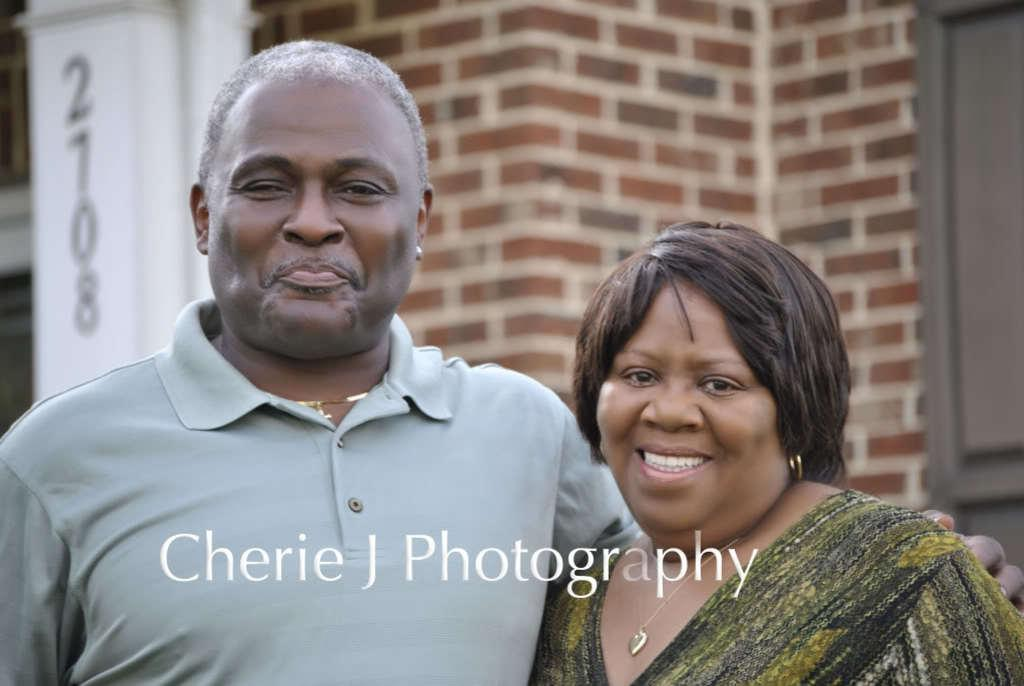How many people are present in the image? There are two people, a man and a woman, present in the image. What expressions do the man and woman have in the image? Both the man and woman are smiling in the image. What can be seen in the background of the image? There is an object with numbers, a wall, and window doors in the background of the image. What type of bean is being served on the plate in the image? There is no plate or bean present in the image. How many hens can be seen in the image? There are no hens present in the image. 